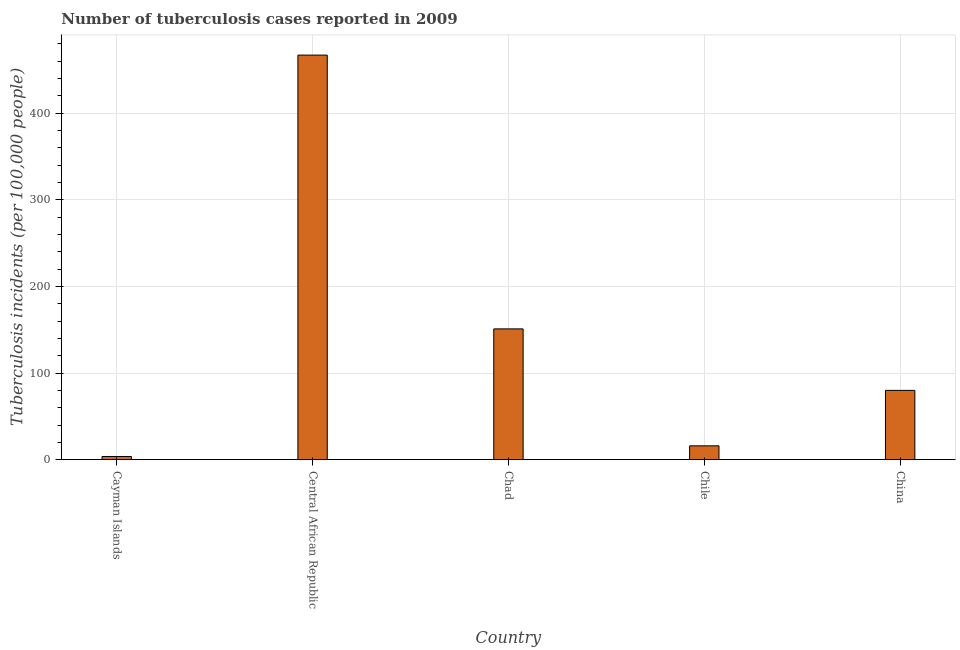Does the graph contain grids?
Give a very brief answer. Yes. What is the title of the graph?
Provide a succinct answer. Number of tuberculosis cases reported in 2009. What is the label or title of the X-axis?
Keep it short and to the point. Country. What is the label or title of the Y-axis?
Your answer should be very brief. Tuberculosis incidents (per 100,0 people). What is the number of tuberculosis incidents in Central African Republic?
Provide a succinct answer. 467. Across all countries, what is the maximum number of tuberculosis incidents?
Your response must be concise. 467. In which country was the number of tuberculosis incidents maximum?
Offer a terse response. Central African Republic. In which country was the number of tuberculosis incidents minimum?
Give a very brief answer. Cayman Islands. What is the sum of the number of tuberculosis incidents?
Your response must be concise. 717.7. What is the difference between the number of tuberculosis incidents in Central African Republic and China?
Provide a short and direct response. 387. What is the average number of tuberculosis incidents per country?
Provide a succinct answer. 143.54. In how many countries, is the number of tuberculosis incidents greater than 140 ?
Offer a very short reply. 2. What is the ratio of the number of tuberculosis incidents in Cayman Islands to that in Central African Republic?
Ensure brevity in your answer.  0.01. Is the number of tuberculosis incidents in Cayman Islands less than that in Central African Republic?
Offer a terse response. Yes. Is the difference between the number of tuberculosis incidents in Chad and Chile greater than the difference between any two countries?
Offer a very short reply. No. What is the difference between the highest and the second highest number of tuberculosis incidents?
Make the answer very short. 316. What is the difference between the highest and the lowest number of tuberculosis incidents?
Give a very brief answer. 463.3. In how many countries, is the number of tuberculosis incidents greater than the average number of tuberculosis incidents taken over all countries?
Give a very brief answer. 2. How many bars are there?
Offer a terse response. 5. Are all the bars in the graph horizontal?
Provide a short and direct response. No. How many countries are there in the graph?
Offer a terse response. 5. What is the difference between two consecutive major ticks on the Y-axis?
Provide a short and direct response. 100. Are the values on the major ticks of Y-axis written in scientific E-notation?
Make the answer very short. No. What is the Tuberculosis incidents (per 100,000 people) of Central African Republic?
Provide a succinct answer. 467. What is the Tuberculosis incidents (per 100,000 people) in Chad?
Provide a succinct answer. 151. What is the Tuberculosis incidents (per 100,000 people) of Chile?
Make the answer very short. 16. What is the difference between the Tuberculosis incidents (per 100,000 people) in Cayman Islands and Central African Republic?
Your answer should be very brief. -463.3. What is the difference between the Tuberculosis incidents (per 100,000 people) in Cayman Islands and Chad?
Offer a very short reply. -147.3. What is the difference between the Tuberculosis incidents (per 100,000 people) in Cayman Islands and Chile?
Your answer should be compact. -12.3. What is the difference between the Tuberculosis incidents (per 100,000 people) in Cayman Islands and China?
Offer a terse response. -76.3. What is the difference between the Tuberculosis incidents (per 100,000 people) in Central African Republic and Chad?
Your answer should be very brief. 316. What is the difference between the Tuberculosis incidents (per 100,000 people) in Central African Republic and Chile?
Provide a short and direct response. 451. What is the difference between the Tuberculosis incidents (per 100,000 people) in Central African Republic and China?
Ensure brevity in your answer.  387. What is the difference between the Tuberculosis incidents (per 100,000 people) in Chad and Chile?
Provide a succinct answer. 135. What is the difference between the Tuberculosis incidents (per 100,000 people) in Chile and China?
Your answer should be compact. -64. What is the ratio of the Tuberculosis incidents (per 100,000 people) in Cayman Islands to that in Central African Republic?
Provide a succinct answer. 0.01. What is the ratio of the Tuberculosis incidents (per 100,000 people) in Cayman Islands to that in Chad?
Give a very brief answer. 0.03. What is the ratio of the Tuberculosis incidents (per 100,000 people) in Cayman Islands to that in Chile?
Make the answer very short. 0.23. What is the ratio of the Tuberculosis incidents (per 100,000 people) in Cayman Islands to that in China?
Offer a very short reply. 0.05. What is the ratio of the Tuberculosis incidents (per 100,000 people) in Central African Republic to that in Chad?
Offer a terse response. 3.09. What is the ratio of the Tuberculosis incidents (per 100,000 people) in Central African Republic to that in Chile?
Make the answer very short. 29.19. What is the ratio of the Tuberculosis incidents (per 100,000 people) in Central African Republic to that in China?
Ensure brevity in your answer.  5.84. What is the ratio of the Tuberculosis incidents (per 100,000 people) in Chad to that in Chile?
Give a very brief answer. 9.44. What is the ratio of the Tuberculosis incidents (per 100,000 people) in Chad to that in China?
Make the answer very short. 1.89. What is the ratio of the Tuberculosis incidents (per 100,000 people) in Chile to that in China?
Give a very brief answer. 0.2. 